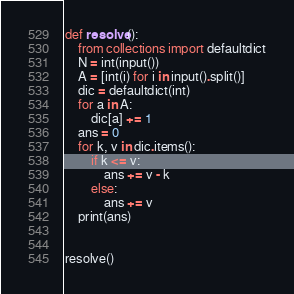<code> <loc_0><loc_0><loc_500><loc_500><_Python_>def resolve():
    from collections import defaultdict
    N = int(input())
    A = [int(i) for i in input().split()]
    dic = defaultdict(int)
    for a in A:
        dic[a] += 1
    ans = 0
    for k, v in dic.items():
        if k <= v:
            ans += v - k
        else:
            ans += v
    print(ans)


resolve()
</code> 